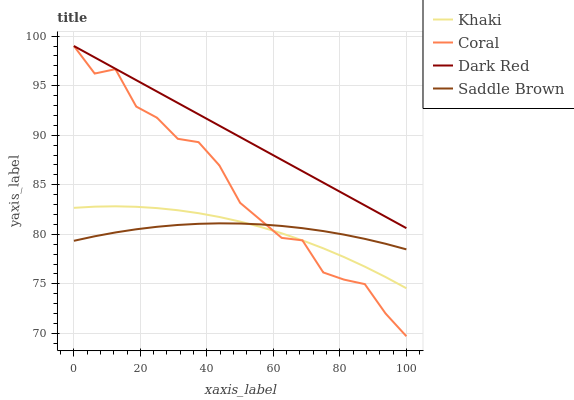Does Saddle Brown have the minimum area under the curve?
Answer yes or no. Yes. Does Dark Red have the maximum area under the curve?
Answer yes or no. Yes. Does Coral have the minimum area under the curve?
Answer yes or no. No. Does Coral have the maximum area under the curve?
Answer yes or no. No. Is Dark Red the smoothest?
Answer yes or no. Yes. Is Coral the roughest?
Answer yes or no. Yes. Is Khaki the smoothest?
Answer yes or no. No. Is Khaki the roughest?
Answer yes or no. No. Does Khaki have the lowest value?
Answer yes or no. No. Does Coral have the highest value?
Answer yes or no. Yes. Does Khaki have the highest value?
Answer yes or no. No. Is Khaki less than Dark Red?
Answer yes or no. Yes. Is Dark Red greater than Saddle Brown?
Answer yes or no. Yes. Does Khaki intersect Saddle Brown?
Answer yes or no. Yes. Is Khaki less than Saddle Brown?
Answer yes or no. No. Is Khaki greater than Saddle Brown?
Answer yes or no. No. Does Khaki intersect Dark Red?
Answer yes or no. No. 